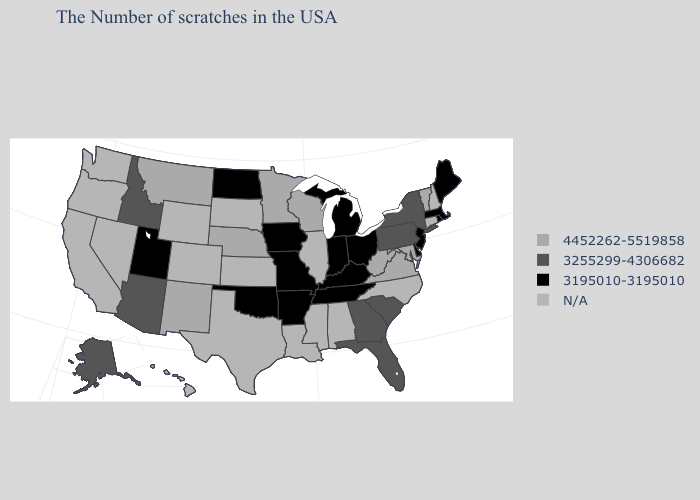Name the states that have a value in the range 3195010-3195010?
Concise answer only. Maine, Massachusetts, Rhode Island, New Jersey, Delaware, Ohio, Michigan, Kentucky, Indiana, Tennessee, Missouri, Arkansas, Iowa, Oklahoma, North Dakota, Utah. Name the states that have a value in the range 3255299-4306682?
Short answer required. New York, Pennsylvania, South Carolina, Florida, Georgia, Arizona, Idaho, Alaska. Does Minnesota have the highest value in the MidWest?
Keep it brief. Yes. What is the highest value in the MidWest ?
Answer briefly. 4452262-5519858. Does Michigan have the highest value in the MidWest?
Answer briefly. No. Which states hav the highest value in the South?
Write a very short answer. Maryland, Virginia, West Virginia. What is the value of Tennessee?
Answer briefly. 3195010-3195010. What is the value of Massachusetts?
Concise answer only. 3195010-3195010. Is the legend a continuous bar?
Concise answer only. No. What is the highest value in states that border Delaware?
Write a very short answer. 4452262-5519858. What is the highest value in the USA?
Keep it brief. 4452262-5519858. What is the value of Pennsylvania?
Answer briefly. 3255299-4306682. Name the states that have a value in the range 3255299-4306682?
Short answer required. New York, Pennsylvania, South Carolina, Florida, Georgia, Arizona, Idaho, Alaska. How many symbols are there in the legend?
Keep it brief. 4. 